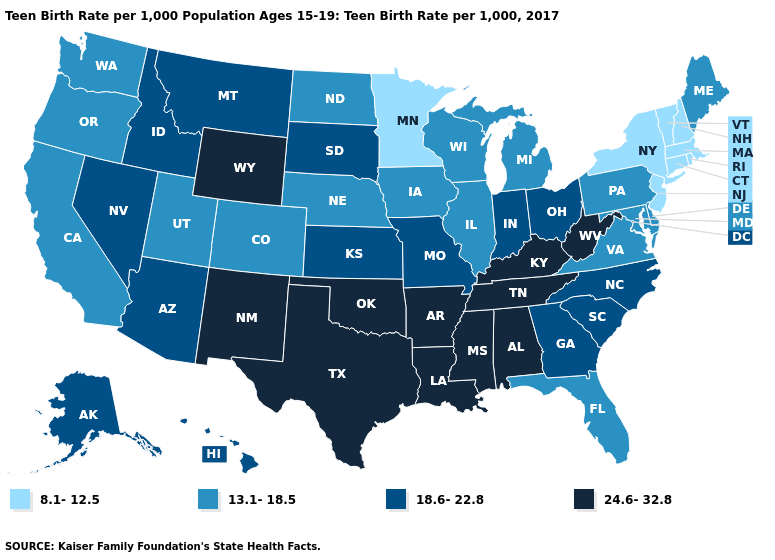Name the states that have a value in the range 18.6-22.8?
Quick response, please. Alaska, Arizona, Georgia, Hawaii, Idaho, Indiana, Kansas, Missouri, Montana, Nevada, North Carolina, Ohio, South Carolina, South Dakota. Which states hav the highest value in the MidWest?
Write a very short answer. Indiana, Kansas, Missouri, Ohio, South Dakota. What is the value of New Hampshire?
Short answer required. 8.1-12.5. What is the value of Maryland?
Answer briefly. 13.1-18.5. Name the states that have a value in the range 24.6-32.8?
Concise answer only. Alabama, Arkansas, Kentucky, Louisiana, Mississippi, New Mexico, Oklahoma, Tennessee, Texas, West Virginia, Wyoming. Name the states that have a value in the range 13.1-18.5?
Concise answer only. California, Colorado, Delaware, Florida, Illinois, Iowa, Maine, Maryland, Michigan, Nebraska, North Dakota, Oregon, Pennsylvania, Utah, Virginia, Washington, Wisconsin. Among the states that border Maine , which have the lowest value?
Be succinct. New Hampshire. Which states have the lowest value in the Northeast?
Quick response, please. Connecticut, Massachusetts, New Hampshire, New Jersey, New York, Rhode Island, Vermont. What is the value of New Mexico?
Give a very brief answer. 24.6-32.8. Which states have the highest value in the USA?
Give a very brief answer. Alabama, Arkansas, Kentucky, Louisiana, Mississippi, New Mexico, Oklahoma, Tennessee, Texas, West Virginia, Wyoming. Among the states that border Montana , which have the highest value?
Be succinct. Wyoming. Name the states that have a value in the range 24.6-32.8?
Quick response, please. Alabama, Arkansas, Kentucky, Louisiana, Mississippi, New Mexico, Oklahoma, Tennessee, Texas, West Virginia, Wyoming. Does Maine have the highest value in the Northeast?
Give a very brief answer. Yes. What is the highest value in the USA?
Keep it brief. 24.6-32.8. Does Minnesota have the lowest value in the USA?
Quick response, please. Yes. 